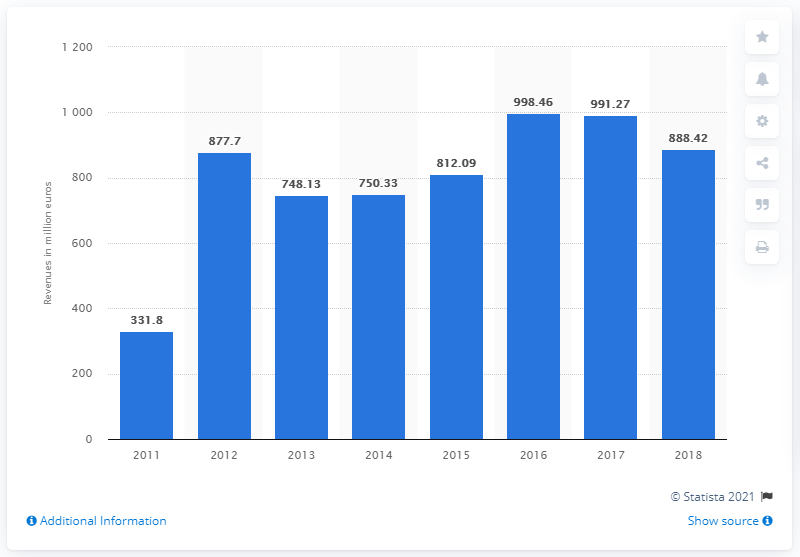Mention a couple of crucial points in this snapshot. The total turnover of Dolce & Gabbana in 2018 was 888.42 million euros. 